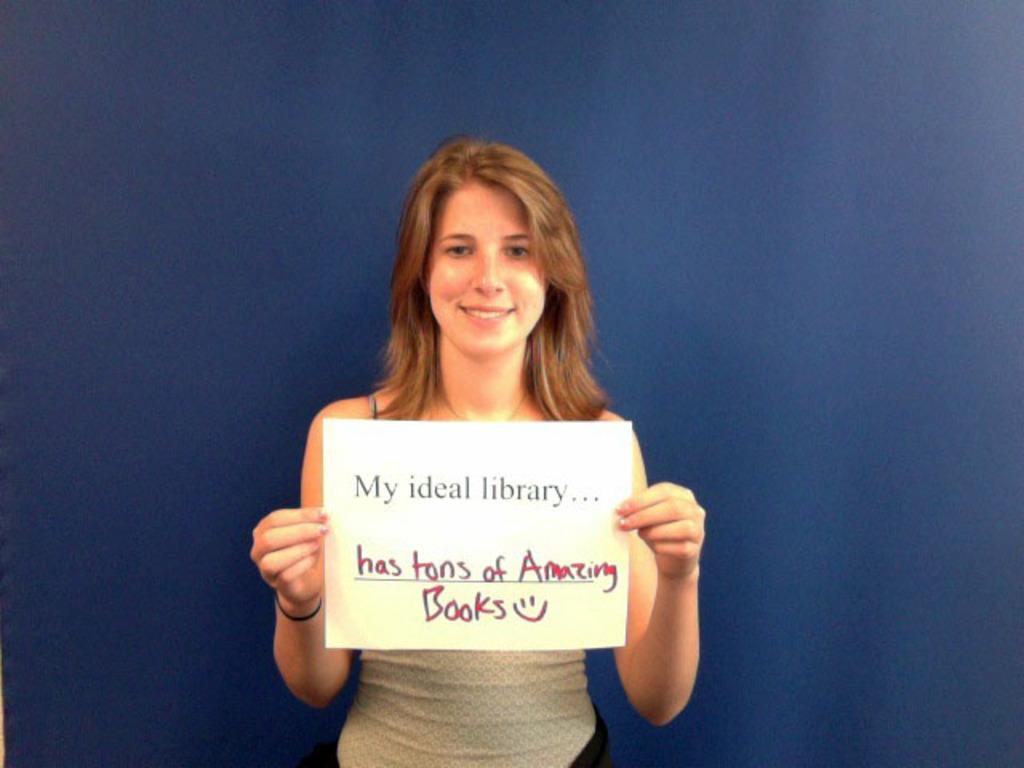Who is the main subject in the image? There is a woman in the image. What is the woman doing in the image? The woman is standing and smiling. What is the woman holding in her hands? The woman is holding a placard in her hands. What type of berry is the woman holding in her hands? The woman is not holding a berry in her hands; she is holding a placard. What is the woman's relationship to the person asking the questions? The facts provided do not give any information about the relationship between the woman in the image and the person asking the questions. 